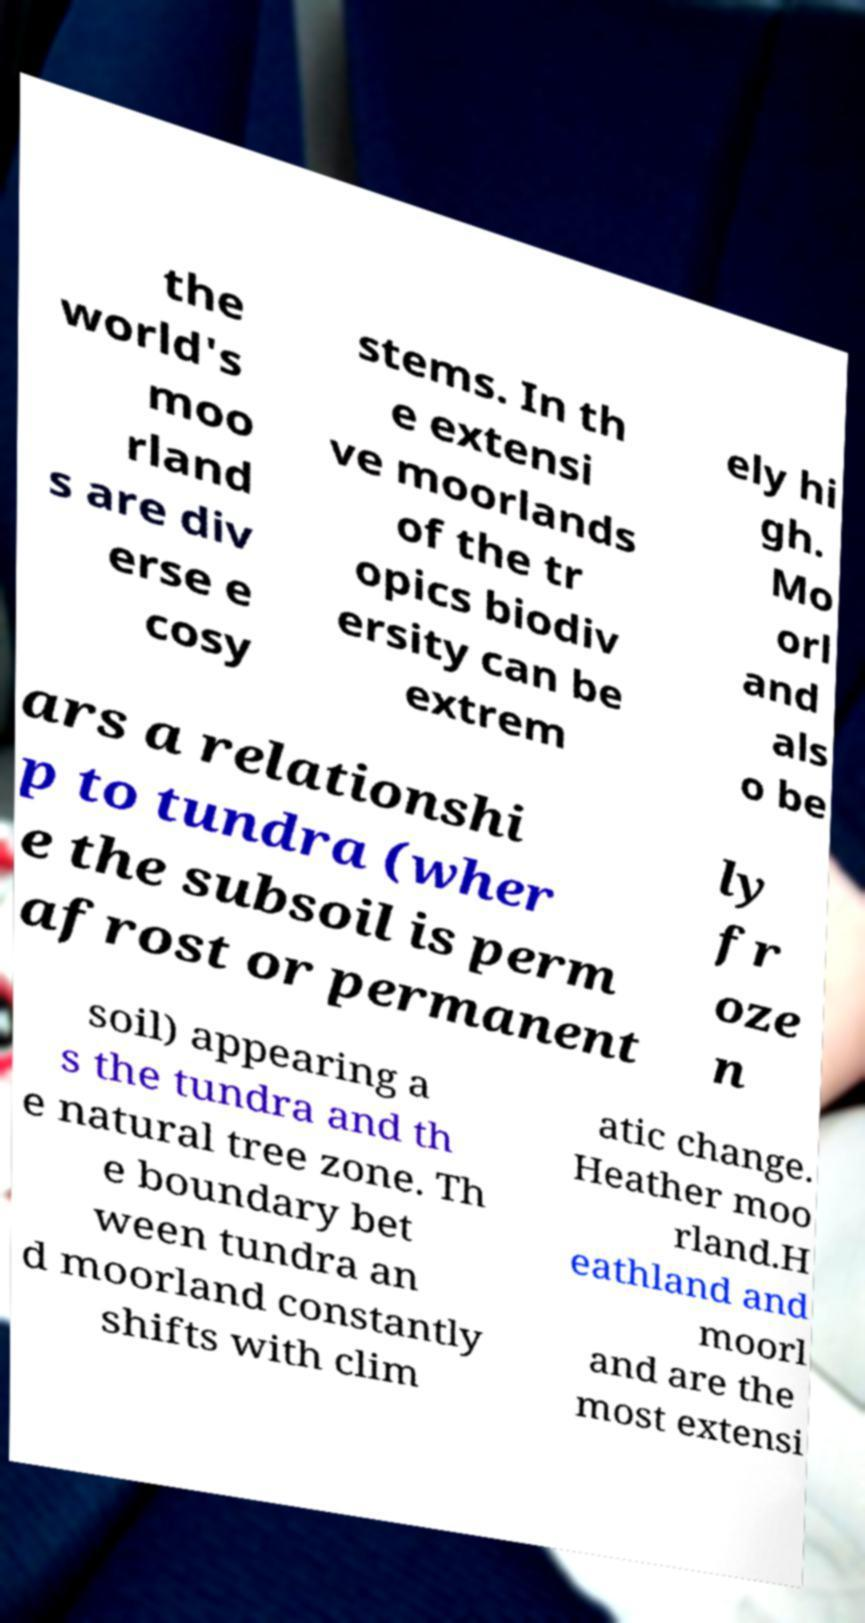What messages or text are displayed in this image? I need them in a readable, typed format. the world's moo rland s are div erse e cosy stems. In th e extensi ve moorlands of the tr opics biodiv ersity can be extrem ely hi gh. Mo orl and als o be ars a relationshi p to tundra (wher e the subsoil is perm afrost or permanent ly fr oze n soil) appearing a s the tundra and th e natural tree zone. Th e boundary bet ween tundra an d moorland constantly shifts with clim atic change. Heather moo rland.H eathland and moorl and are the most extensi 